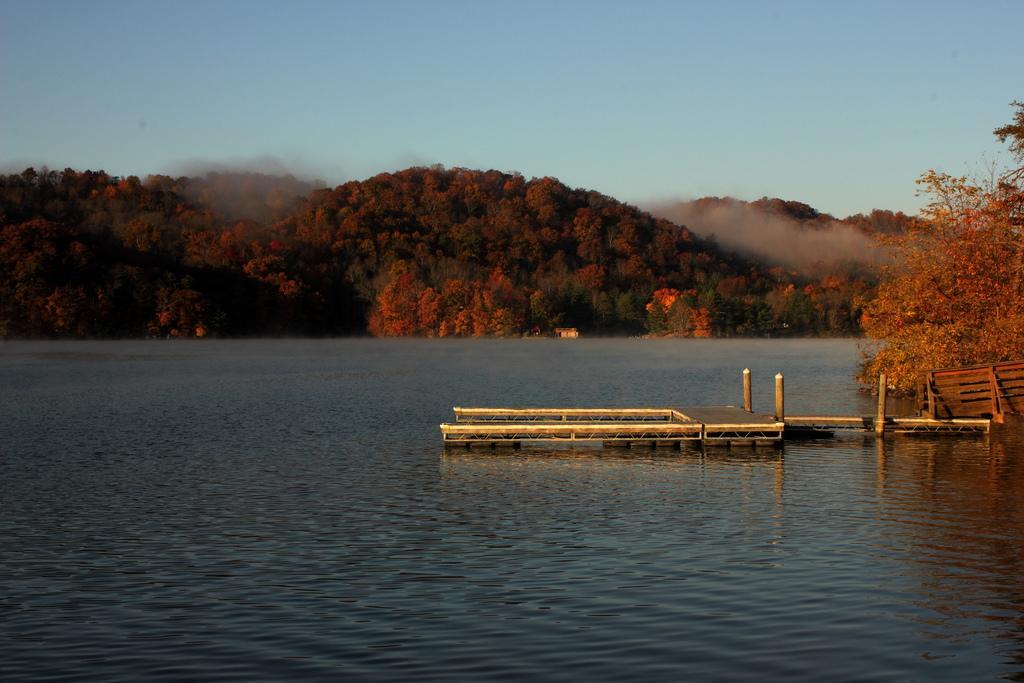Can you describe this image briefly? In this image we can see a deck with poles on the water. We can also see some plants. On the backside we can see a group of trees on the hills and the sky which looks cloudy. 